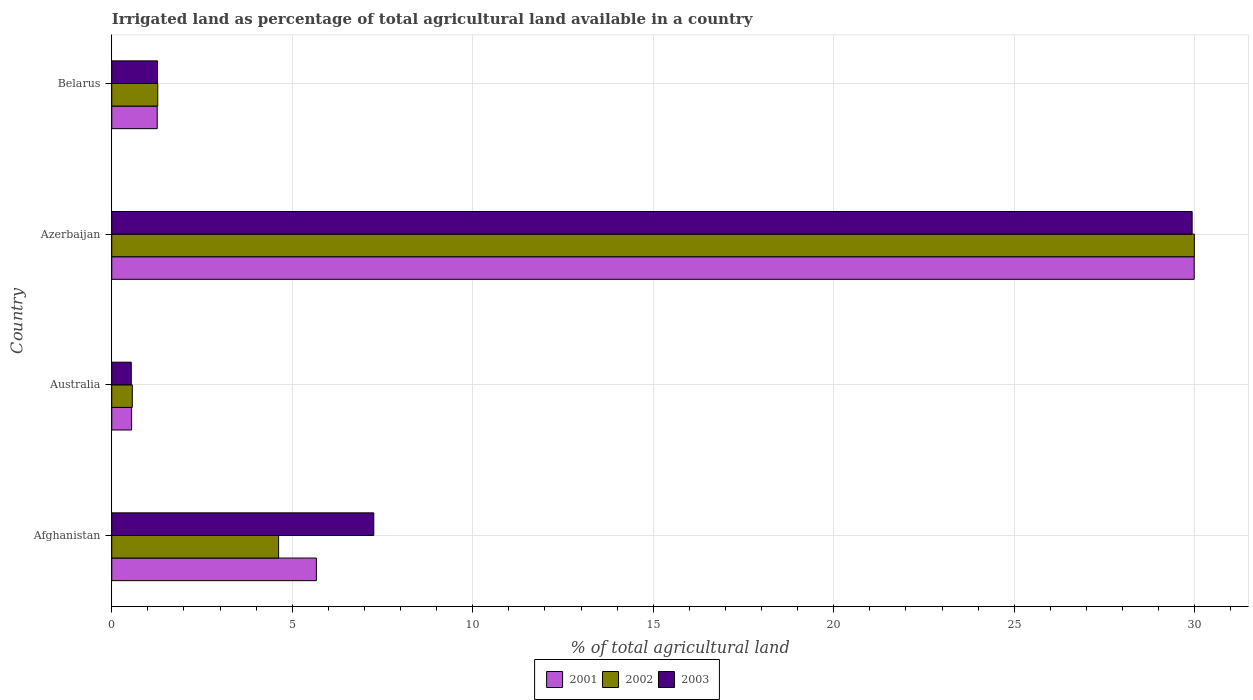How many groups of bars are there?
Give a very brief answer. 4. Are the number of bars per tick equal to the number of legend labels?
Your answer should be very brief. Yes. Are the number of bars on each tick of the Y-axis equal?
Your answer should be very brief. Yes. How many bars are there on the 3rd tick from the top?
Your answer should be very brief. 3. How many bars are there on the 4th tick from the bottom?
Ensure brevity in your answer.  3. What is the label of the 4th group of bars from the top?
Offer a very short reply. Afghanistan. What is the percentage of irrigated land in 2003 in Belarus?
Make the answer very short. 1.27. Across all countries, what is the maximum percentage of irrigated land in 2003?
Your response must be concise. 29.93. Across all countries, what is the minimum percentage of irrigated land in 2002?
Your answer should be very brief. 0.57. In which country was the percentage of irrigated land in 2003 maximum?
Give a very brief answer. Azerbaijan. In which country was the percentage of irrigated land in 2003 minimum?
Your answer should be compact. Australia. What is the total percentage of irrigated land in 2003 in the graph?
Your answer should be very brief. 39. What is the difference between the percentage of irrigated land in 2002 in Australia and that in Belarus?
Make the answer very short. -0.7. What is the difference between the percentage of irrigated land in 2003 in Azerbaijan and the percentage of irrigated land in 2001 in Australia?
Offer a very short reply. 29.38. What is the average percentage of irrigated land in 2001 per country?
Your answer should be compact. 9.37. What is the difference between the percentage of irrigated land in 2001 and percentage of irrigated land in 2002 in Azerbaijan?
Provide a short and direct response. -0. In how many countries, is the percentage of irrigated land in 2002 greater than 16 %?
Make the answer very short. 1. What is the ratio of the percentage of irrigated land in 2001 in Afghanistan to that in Belarus?
Offer a terse response. 4.5. Is the percentage of irrigated land in 2003 in Azerbaijan less than that in Belarus?
Your answer should be compact. No. Is the difference between the percentage of irrigated land in 2001 in Afghanistan and Azerbaijan greater than the difference between the percentage of irrigated land in 2002 in Afghanistan and Azerbaijan?
Your answer should be very brief. Yes. What is the difference between the highest and the second highest percentage of irrigated land in 2002?
Provide a short and direct response. 25.37. What is the difference between the highest and the lowest percentage of irrigated land in 2003?
Your answer should be very brief. 29.39. What does the 1st bar from the bottom in Afghanistan represents?
Offer a terse response. 2001. Are all the bars in the graph horizontal?
Give a very brief answer. Yes. What is the difference between two consecutive major ticks on the X-axis?
Offer a very short reply. 5. Does the graph contain grids?
Your answer should be very brief. Yes. Where does the legend appear in the graph?
Ensure brevity in your answer.  Bottom center. What is the title of the graph?
Give a very brief answer. Irrigated land as percentage of total agricultural land available in a country. Does "2009" appear as one of the legend labels in the graph?
Your answer should be compact. No. What is the label or title of the X-axis?
Keep it short and to the point. % of total agricultural land. What is the % of total agricultural land in 2001 in Afghanistan?
Make the answer very short. 5.67. What is the % of total agricultural land of 2002 in Afghanistan?
Offer a very short reply. 4.62. What is the % of total agricultural land of 2003 in Afghanistan?
Provide a short and direct response. 7.26. What is the % of total agricultural land of 2001 in Australia?
Ensure brevity in your answer.  0.55. What is the % of total agricultural land of 2002 in Australia?
Give a very brief answer. 0.57. What is the % of total agricultural land of 2003 in Australia?
Keep it short and to the point. 0.54. What is the % of total agricultural land of 2001 in Azerbaijan?
Your answer should be very brief. 29.99. What is the % of total agricultural land in 2002 in Azerbaijan?
Your answer should be very brief. 29.99. What is the % of total agricultural land in 2003 in Azerbaijan?
Ensure brevity in your answer.  29.93. What is the % of total agricultural land of 2001 in Belarus?
Keep it short and to the point. 1.26. What is the % of total agricultural land of 2002 in Belarus?
Your answer should be very brief. 1.27. What is the % of total agricultural land in 2003 in Belarus?
Your answer should be compact. 1.27. Across all countries, what is the maximum % of total agricultural land of 2001?
Your answer should be compact. 29.99. Across all countries, what is the maximum % of total agricultural land of 2002?
Give a very brief answer. 29.99. Across all countries, what is the maximum % of total agricultural land in 2003?
Keep it short and to the point. 29.93. Across all countries, what is the minimum % of total agricultural land of 2001?
Keep it short and to the point. 0.55. Across all countries, what is the minimum % of total agricultural land in 2002?
Provide a succinct answer. 0.57. Across all countries, what is the minimum % of total agricultural land of 2003?
Provide a short and direct response. 0.54. What is the total % of total agricultural land in 2001 in the graph?
Keep it short and to the point. 37.46. What is the total % of total agricultural land of 2002 in the graph?
Provide a succinct answer. 36.46. What is the total % of total agricultural land in 2003 in the graph?
Provide a succinct answer. 39. What is the difference between the % of total agricultural land in 2001 in Afghanistan and that in Australia?
Your response must be concise. 5.12. What is the difference between the % of total agricultural land in 2002 in Afghanistan and that in Australia?
Offer a very short reply. 4.05. What is the difference between the % of total agricultural land in 2003 in Afghanistan and that in Australia?
Your answer should be compact. 6.72. What is the difference between the % of total agricultural land in 2001 in Afghanistan and that in Azerbaijan?
Ensure brevity in your answer.  -24.32. What is the difference between the % of total agricultural land in 2002 in Afghanistan and that in Azerbaijan?
Offer a terse response. -25.37. What is the difference between the % of total agricultural land in 2003 in Afghanistan and that in Azerbaijan?
Provide a short and direct response. -22.67. What is the difference between the % of total agricultural land in 2001 in Afghanistan and that in Belarus?
Your answer should be compact. 4.41. What is the difference between the % of total agricultural land of 2002 in Afghanistan and that in Belarus?
Make the answer very short. 3.35. What is the difference between the % of total agricultural land in 2003 in Afghanistan and that in Belarus?
Provide a short and direct response. 5.99. What is the difference between the % of total agricultural land in 2001 in Australia and that in Azerbaijan?
Your answer should be very brief. -29.44. What is the difference between the % of total agricultural land of 2002 in Australia and that in Azerbaijan?
Give a very brief answer. -29.42. What is the difference between the % of total agricultural land in 2003 in Australia and that in Azerbaijan?
Your answer should be compact. -29.39. What is the difference between the % of total agricultural land in 2001 in Australia and that in Belarus?
Keep it short and to the point. -0.71. What is the difference between the % of total agricultural land of 2002 in Australia and that in Belarus?
Provide a short and direct response. -0.7. What is the difference between the % of total agricultural land of 2003 in Australia and that in Belarus?
Your answer should be very brief. -0.73. What is the difference between the % of total agricultural land in 2001 in Azerbaijan and that in Belarus?
Make the answer very short. 28.73. What is the difference between the % of total agricultural land of 2002 in Azerbaijan and that in Belarus?
Offer a terse response. 28.72. What is the difference between the % of total agricultural land of 2003 in Azerbaijan and that in Belarus?
Give a very brief answer. 28.66. What is the difference between the % of total agricultural land of 2001 in Afghanistan and the % of total agricultural land of 2002 in Australia?
Keep it short and to the point. 5.1. What is the difference between the % of total agricultural land in 2001 in Afghanistan and the % of total agricultural land in 2003 in Australia?
Keep it short and to the point. 5.13. What is the difference between the % of total agricultural land of 2002 in Afghanistan and the % of total agricultural land of 2003 in Australia?
Give a very brief answer. 4.08. What is the difference between the % of total agricultural land of 2001 in Afghanistan and the % of total agricultural land of 2002 in Azerbaijan?
Your answer should be very brief. -24.32. What is the difference between the % of total agricultural land of 2001 in Afghanistan and the % of total agricultural land of 2003 in Azerbaijan?
Make the answer very short. -24.26. What is the difference between the % of total agricultural land of 2002 in Afghanistan and the % of total agricultural land of 2003 in Azerbaijan?
Offer a terse response. -25.31. What is the difference between the % of total agricultural land in 2001 in Afghanistan and the % of total agricultural land in 2002 in Belarus?
Give a very brief answer. 4.39. What is the difference between the % of total agricultural land in 2001 in Afghanistan and the % of total agricultural land in 2003 in Belarus?
Offer a terse response. 4.4. What is the difference between the % of total agricultural land in 2002 in Afghanistan and the % of total agricultural land in 2003 in Belarus?
Your response must be concise. 3.35. What is the difference between the % of total agricultural land in 2001 in Australia and the % of total agricultural land in 2002 in Azerbaijan?
Your answer should be very brief. -29.44. What is the difference between the % of total agricultural land in 2001 in Australia and the % of total agricultural land in 2003 in Azerbaijan?
Your response must be concise. -29.38. What is the difference between the % of total agricultural land in 2002 in Australia and the % of total agricultural land in 2003 in Azerbaijan?
Provide a short and direct response. -29.36. What is the difference between the % of total agricultural land of 2001 in Australia and the % of total agricultural land of 2002 in Belarus?
Your response must be concise. -0.72. What is the difference between the % of total agricultural land in 2001 in Australia and the % of total agricultural land in 2003 in Belarus?
Offer a terse response. -0.72. What is the difference between the % of total agricultural land in 2002 in Australia and the % of total agricultural land in 2003 in Belarus?
Provide a succinct answer. -0.7. What is the difference between the % of total agricultural land in 2001 in Azerbaijan and the % of total agricultural land in 2002 in Belarus?
Provide a succinct answer. 28.71. What is the difference between the % of total agricultural land of 2001 in Azerbaijan and the % of total agricultural land of 2003 in Belarus?
Provide a short and direct response. 28.72. What is the difference between the % of total agricultural land in 2002 in Azerbaijan and the % of total agricultural land in 2003 in Belarus?
Offer a very short reply. 28.72. What is the average % of total agricultural land in 2001 per country?
Offer a terse response. 9.37. What is the average % of total agricultural land of 2002 per country?
Your answer should be very brief. 9.11. What is the average % of total agricultural land in 2003 per country?
Give a very brief answer. 9.75. What is the difference between the % of total agricultural land of 2001 and % of total agricultural land of 2002 in Afghanistan?
Ensure brevity in your answer.  1.05. What is the difference between the % of total agricultural land in 2001 and % of total agricultural land in 2003 in Afghanistan?
Make the answer very short. -1.59. What is the difference between the % of total agricultural land of 2002 and % of total agricultural land of 2003 in Afghanistan?
Offer a very short reply. -2.64. What is the difference between the % of total agricultural land in 2001 and % of total agricultural land in 2002 in Australia?
Make the answer very short. -0.02. What is the difference between the % of total agricultural land of 2001 and % of total agricultural land of 2003 in Australia?
Your response must be concise. 0.01. What is the difference between the % of total agricultural land of 2002 and % of total agricultural land of 2003 in Australia?
Keep it short and to the point. 0.03. What is the difference between the % of total agricultural land of 2001 and % of total agricultural land of 2002 in Azerbaijan?
Make the answer very short. -0. What is the difference between the % of total agricultural land of 2001 and % of total agricultural land of 2003 in Azerbaijan?
Make the answer very short. 0.06. What is the difference between the % of total agricultural land of 2002 and % of total agricultural land of 2003 in Azerbaijan?
Your answer should be compact. 0.06. What is the difference between the % of total agricultural land of 2001 and % of total agricultural land of 2002 in Belarus?
Give a very brief answer. -0.01. What is the difference between the % of total agricultural land in 2001 and % of total agricultural land in 2003 in Belarus?
Provide a short and direct response. -0.01. What is the difference between the % of total agricultural land in 2002 and % of total agricultural land in 2003 in Belarus?
Keep it short and to the point. 0.01. What is the ratio of the % of total agricultural land in 2001 in Afghanistan to that in Australia?
Offer a very short reply. 10.31. What is the ratio of the % of total agricultural land of 2002 in Afghanistan to that in Australia?
Offer a very short reply. 8.12. What is the ratio of the % of total agricultural land in 2003 in Afghanistan to that in Australia?
Keep it short and to the point. 13.42. What is the ratio of the % of total agricultural land of 2001 in Afghanistan to that in Azerbaijan?
Provide a short and direct response. 0.19. What is the ratio of the % of total agricultural land of 2002 in Afghanistan to that in Azerbaijan?
Offer a very short reply. 0.15. What is the ratio of the % of total agricultural land of 2003 in Afghanistan to that in Azerbaijan?
Your response must be concise. 0.24. What is the ratio of the % of total agricultural land of 2001 in Afghanistan to that in Belarus?
Your answer should be very brief. 4.5. What is the ratio of the % of total agricultural land of 2002 in Afghanistan to that in Belarus?
Your response must be concise. 3.63. What is the ratio of the % of total agricultural land in 2003 in Afghanistan to that in Belarus?
Make the answer very short. 5.72. What is the ratio of the % of total agricultural land in 2001 in Australia to that in Azerbaijan?
Make the answer very short. 0.02. What is the ratio of the % of total agricultural land in 2002 in Australia to that in Azerbaijan?
Ensure brevity in your answer.  0.02. What is the ratio of the % of total agricultural land in 2003 in Australia to that in Azerbaijan?
Offer a terse response. 0.02. What is the ratio of the % of total agricultural land in 2001 in Australia to that in Belarus?
Provide a succinct answer. 0.44. What is the ratio of the % of total agricultural land in 2002 in Australia to that in Belarus?
Provide a short and direct response. 0.45. What is the ratio of the % of total agricultural land of 2003 in Australia to that in Belarus?
Keep it short and to the point. 0.43. What is the ratio of the % of total agricultural land in 2001 in Azerbaijan to that in Belarus?
Offer a very short reply. 23.8. What is the ratio of the % of total agricultural land of 2002 in Azerbaijan to that in Belarus?
Give a very brief answer. 23.54. What is the ratio of the % of total agricultural land of 2003 in Azerbaijan to that in Belarus?
Provide a succinct answer. 23.59. What is the difference between the highest and the second highest % of total agricultural land in 2001?
Offer a very short reply. 24.32. What is the difference between the highest and the second highest % of total agricultural land of 2002?
Your answer should be very brief. 25.37. What is the difference between the highest and the second highest % of total agricultural land in 2003?
Provide a short and direct response. 22.67. What is the difference between the highest and the lowest % of total agricultural land of 2001?
Your answer should be compact. 29.44. What is the difference between the highest and the lowest % of total agricultural land in 2002?
Your response must be concise. 29.42. What is the difference between the highest and the lowest % of total agricultural land of 2003?
Make the answer very short. 29.39. 